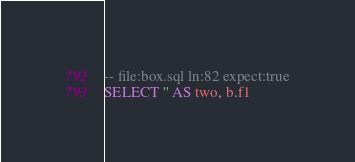<code> <loc_0><loc_0><loc_500><loc_500><_SQL_>-- file:box.sql ln:82 expect:true
SELECT '' AS two, b.f1</code> 